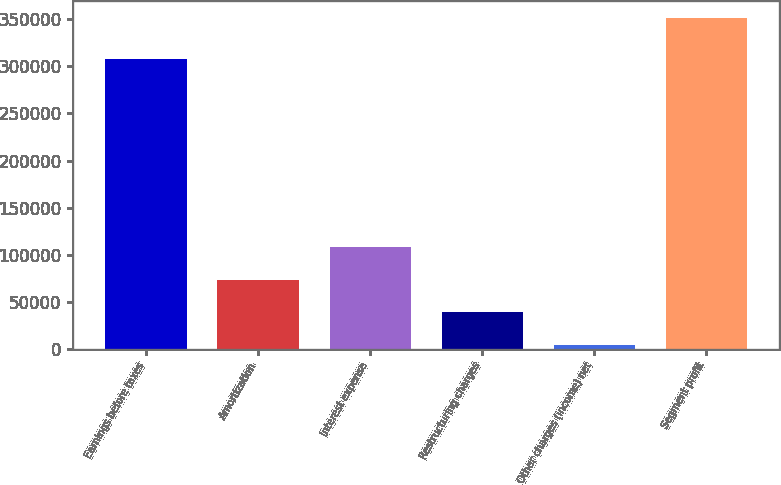Convert chart. <chart><loc_0><loc_0><loc_500><loc_500><bar_chart><fcel>Earnings before taxes<fcel>Amortization<fcel>Interest expense<fcel>Restructuring charges<fcel>Other charges (income) net<fcel>Segment profit<nl><fcel>307513<fcel>73619.6<fcel>108347<fcel>38891.8<fcel>4164<fcel>351442<nl></chart> 